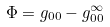<formula> <loc_0><loc_0><loc_500><loc_500>\Phi = g _ { 0 0 } - g _ { 0 0 } ^ { \infty }</formula> 